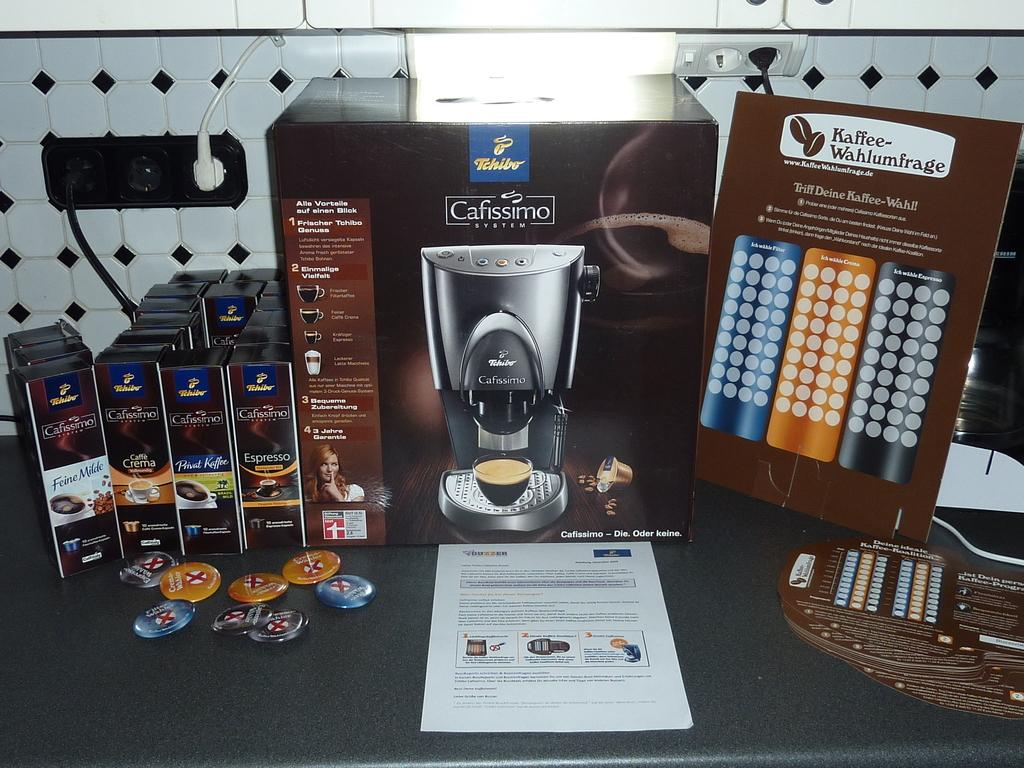<image>
Render a clear and concise summary of the photo. A box for a Cafissimo coffee system is surrounded by pods and instruction cards. 